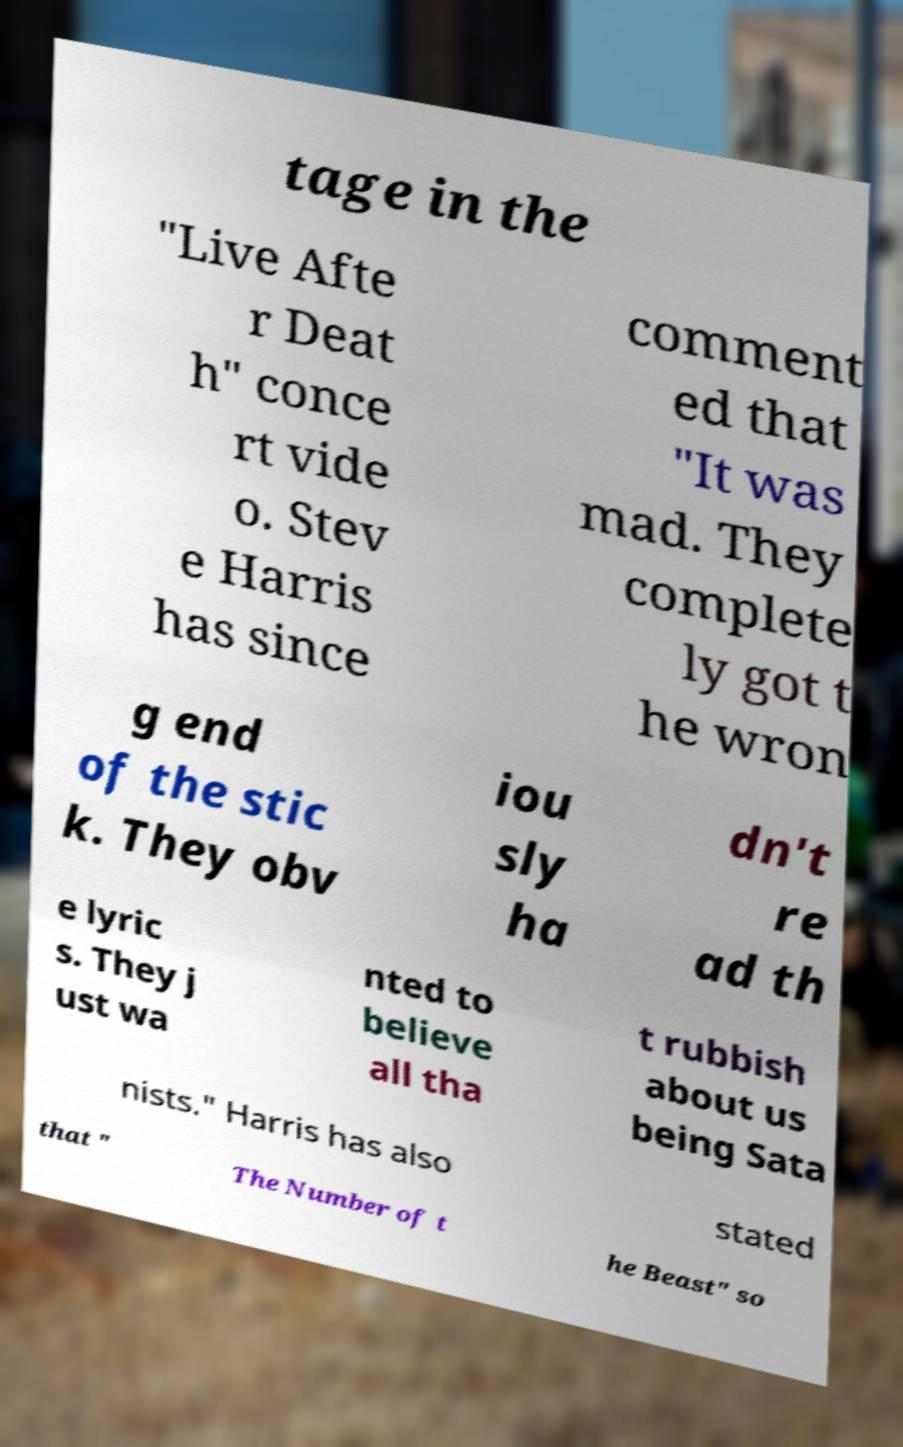Could you extract and type out the text from this image? tage in the "Live Afte r Deat h" conce rt vide o. Stev e Harris has since comment ed that "It was mad. They complete ly got t he wron g end of the stic k. They obv iou sly ha dn't re ad th e lyric s. They j ust wa nted to believe all tha t rubbish about us being Sata nists." Harris has also stated that " The Number of t he Beast" so 